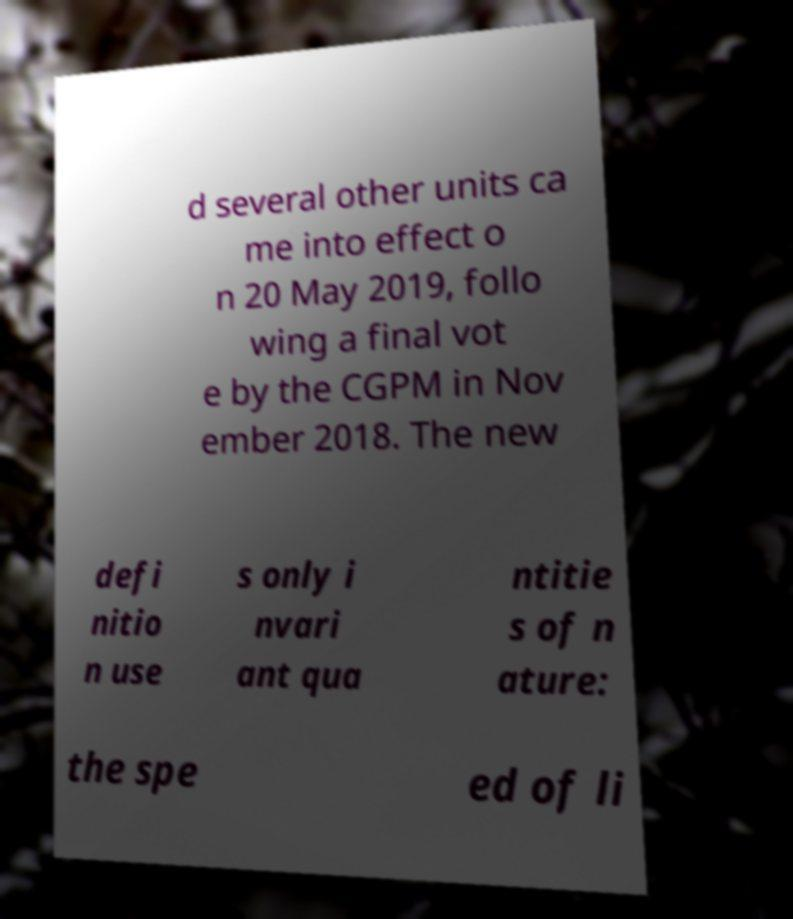I need the written content from this picture converted into text. Can you do that? d several other units ca me into effect o n 20 May 2019, follo wing a final vot e by the CGPM in Nov ember 2018. The new defi nitio n use s only i nvari ant qua ntitie s of n ature: the spe ed of li 